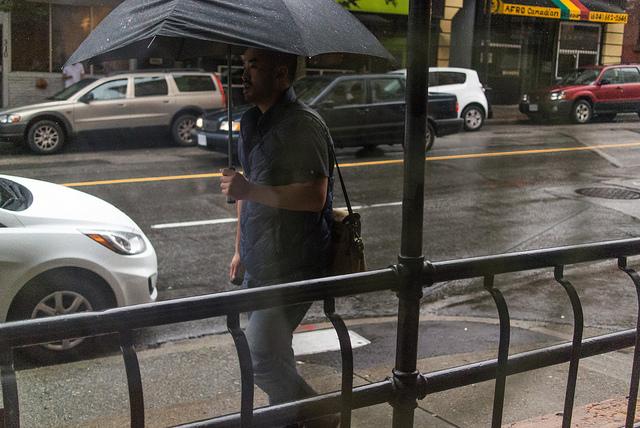What is the yellow line on the road?
Concise answer only. Center line. How many people in the image?
Quick response, please. 1. How many buses are there?
Be succinct. 0. Is it raining?
Short answer required. Yes. 